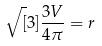Convert formula to latex. <formula><loc_0><loc_0><loc_500><loc_500>\sqrt { [ } 3 ] { \frac { 3 V } { 4 \pi } } = r</formula> 